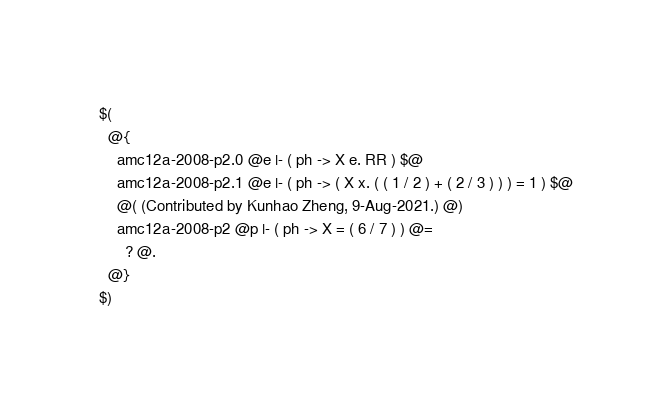Convert code to text. <code><loc_0><loc_0><loc_500><loc_500><_ObjectiveC_>$(
  @{
    amc12a-2008-p2.0 @e |- ( ph -> X e. RR ) $@
    amc12a-2008-p2.1 @e |- ( ph -> ( X x. ( ( 1 / 2 ) + ( 2 / 3 ) ) ) = 1 ) $@
    @( (Contributed by Kunhao Zheng, 9-Aug-2021.) @)
    amc12a-2008-p2 @p |- ( ph -> X = ( 6 / 7 ) ) @=
      ? @.
  @}
$)
</code> 